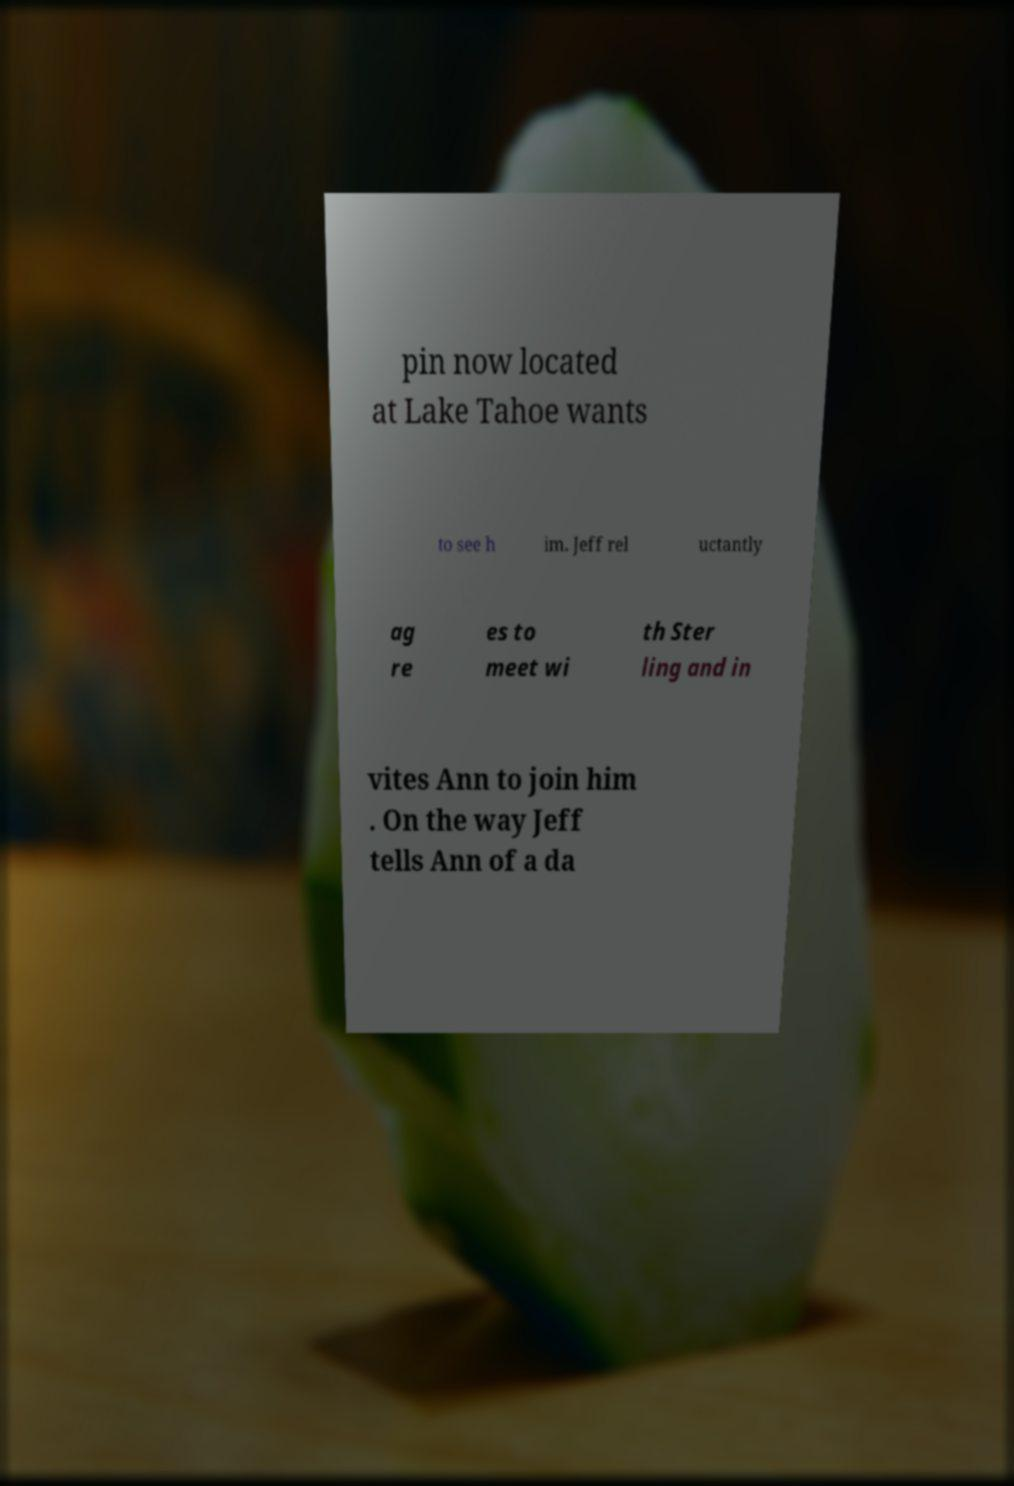Please identify and transcribe the text found in this image. pin now located at Lake Tahoe wants to see h im. Jeff rel uctantly ag re es to meet wi th Ster ling and in vites Ann to join him . On the way Jeff tells Ann of a da 